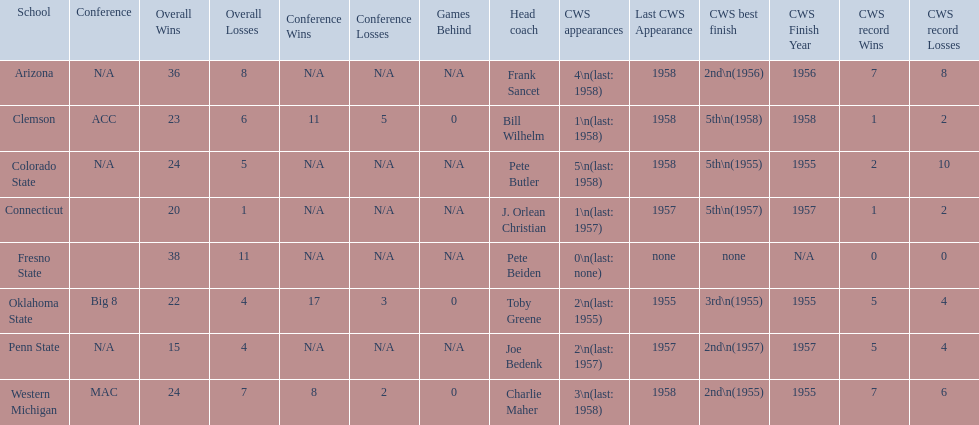What are the listed schools? Arizona, Clemson, Colorado State, Connecticut, Fresno State, Oklahoma State, Penn State, Western Michigan. Which are clemson and western michigan? Clemson, Western Michigan. What are their corresponding numbers of cws appearances? 1\n(last: 1958), 3\n(last: 1958). I'm looking to parse the entire table for insights. Could you assist me with that? {'header': ['School', 'Conference', 'Overall Wins', 'Overall Losses', 'Conference Wins', 'Conference Losses', 'Games Behind', 'Head coach', 'CWS appearances', 'Last CWS Appearance', 'CWS best finish', 'CWS Finish Year', 'CWS record Wins', 'CWS record Losses'], 'rows': [['Arizona', 'N/A', '36', '8', 'N/A', 'N/A', 'N/A', 'Frank Sancet', '4\\n(last: 1958)', '1958', '2nd\\n(1956)', '1956', '7', '8'], ['Clemson', 'ACC', '23', '6', '11', '5', '0', 'Bill Wilhelm', '1\\n(last: 1958)', '1958', '5th\\n(1958)', '1958', '1', '2'], ['Colorado State', 'N/A', '24', '5', 'N/A', 'N/A', 'N/A', 'Pete Butler', '5\\n(last: 1958)', '1958', '5th\\n(1955)', '1955', '2', '10'], ['Connecticut', '', '20', '1', 'N/A', 'N/A', 'N/A', 'J. Orlean Christian', '1\\n(last: 1957)', '1957', '5th\\n(1957)', '1957', '1', '2'], ['Fresno State', '', '38', '11', 'N/A', 'N/A', 'N/A', 'Pete Beiden', '0\\n(last: none)', 'none', 'none', 'N/A', '0', '0'], ['Oklahoma State', 'Big 8', '22', '4', '17', '3', '0', 'Toby Greene', '2\\n(last: 1955)', '1955', '3rd\\n(1955)', '1955', '5', '4'], ['Penn State', 'N/A', '15', '4', 'N/A', 'N/A', 'N/A', 'Joe Bedenk', '2\\n(last: 1957)', '1957', '2nd\\n(1957)', '1957', '5', '4'], ['Western Michigan', 'MAC', '24', '7', '8', '2', '0', 'Charlie Maher', '3\\n(last: 1958)', '1958', '2nd\\n(1955)', '1955', '7', '6']]} Which value is larger? 3\n(last: 1958). To which school does that value belong to? Western Michigan. 